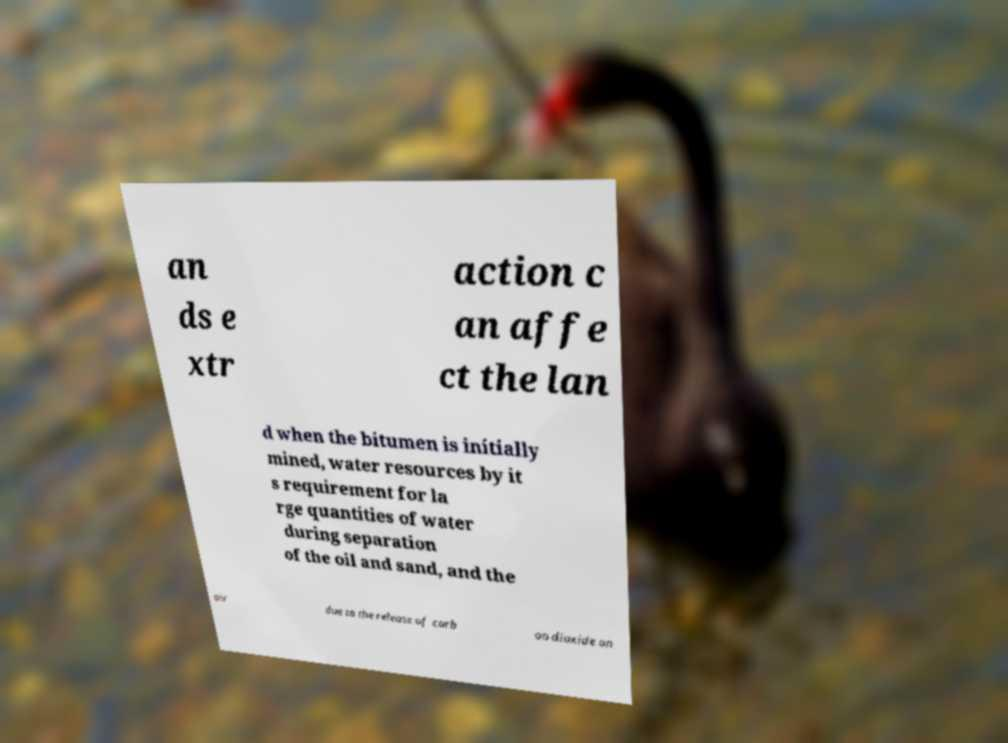Please identify and transcribe the text found in this image. an ds e xtr action c an affe ct the lan d when the bitumen is initially mined, water resources by it s requirement for la rge quantities of water during separation of the oil and sand, and the air due to the release of carb on dioxide an 